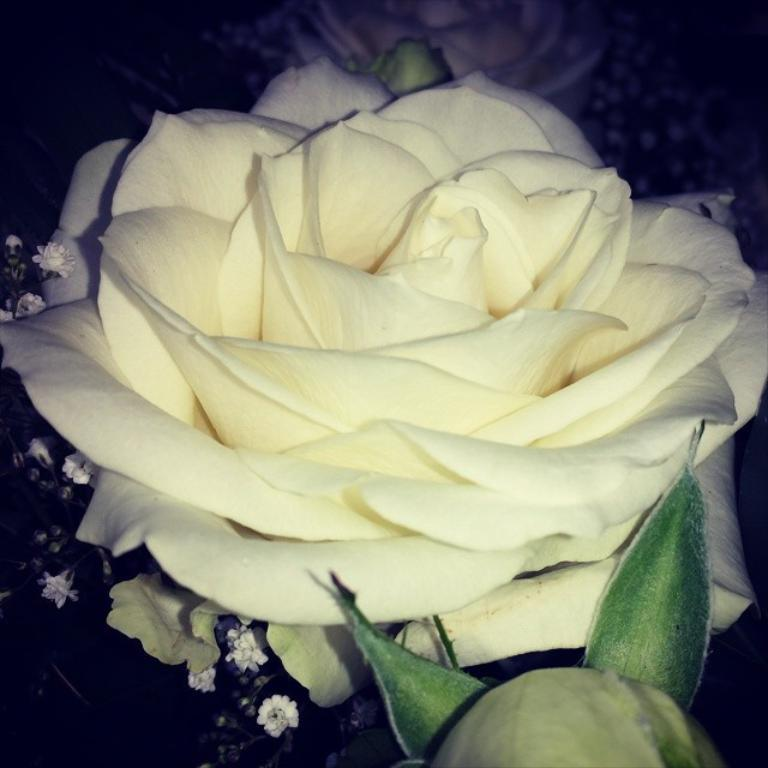What type of flower is in the image? There is a rose flower in the image. What else can be seen in the image besides the flower? There are leaves in the image. How would you describe the background of the image? The background of the image is dark. What type of plastic material is used to create the dust in the image? There is no plastic or dust present in the image; it features a rose flower and leaves against a dark background. 